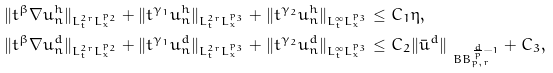Convert formula to latex. <formula><loc_0><loc_0><loc_500><loc_500>& \| t ^ { \beta } \nabla u ^ { h } _ { n } \| _ { L ^ { 2 r } _ { t } L ^ { p _ { 2 } } _ { x } } + \| t ^ { \gamma _ { 1 } } u ^ { h } _ { n } \| _ { L ^ { 2 r } _ { t } L ^ { p _ { 3 } } _ { x } } + \| t ^ { \gamma _ { 2 } } u ^ { h } _ { n } \| _ { L ^ { \infty } _ { t } L ^ { p _ { 3 } } _ { x } } \leq C _ { 1 } \eta , \\ & \| t ^ { \beta } \nabla u ^ { d } _ { n } \| _ { L ^ { 2 r } _ { t } L ^ { p _ { 2 } } _ { x } } + \| t ^ { \gamma _ { 1 } } u ^ { d } _ { n } \| _ { L ^ { 2 r } _ { t } L ^ { p _ { 3 } } _ { x } } + \| t ^ { \gamma _ { 2 } } u ^ { d } _ { n } \| _ { L ^ { \infty } _ { t } L ^ { p _ { 3 } } _ { x } } \leq C _ { 2 } \| \bar { u } ^ { d } \| _ { \ B B _ { p , r } ^ { \frac { d } { p } - 1 } } + C _ { 3 } ,</formula> 